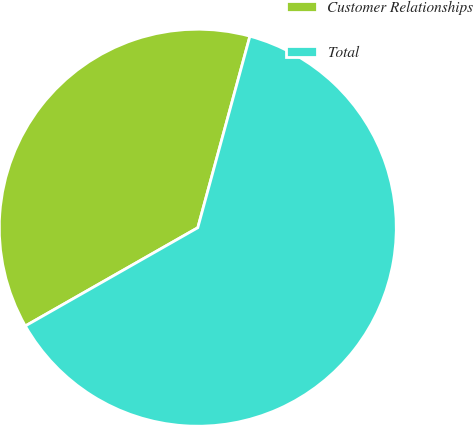Convert chart to OTSL. <chart><loc_0><loc_0><loc_500><loc_500><pie_chart><fcel>Customer Relationships<fcel>Total<nl><fcel>37.47%<fcel>62.53%<nl></chart> 